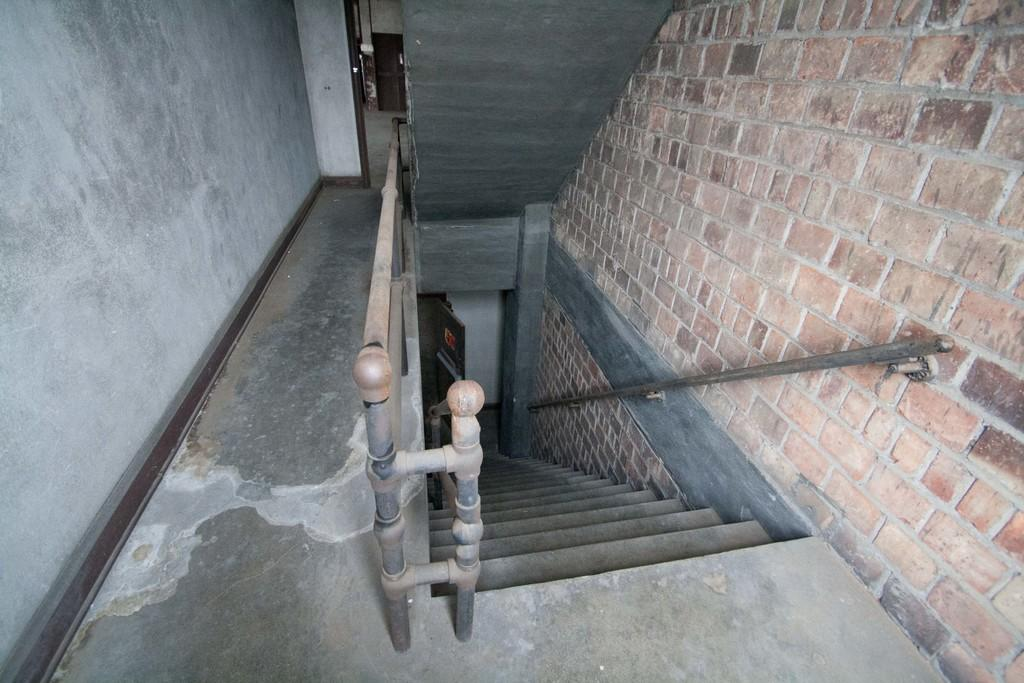What type of location is depicted in the image? The image is an inner view of a building. What part of the building can be seen in the image? There is a downstairs area visible in the image. What architectural feature is present in the image? There is a fence in the image. What other structural element can be seen in the image? There is a wall in the image. What type of tail can be seen on the animal in the image? There are no animals present in the image, so there is no tail to be seen. 